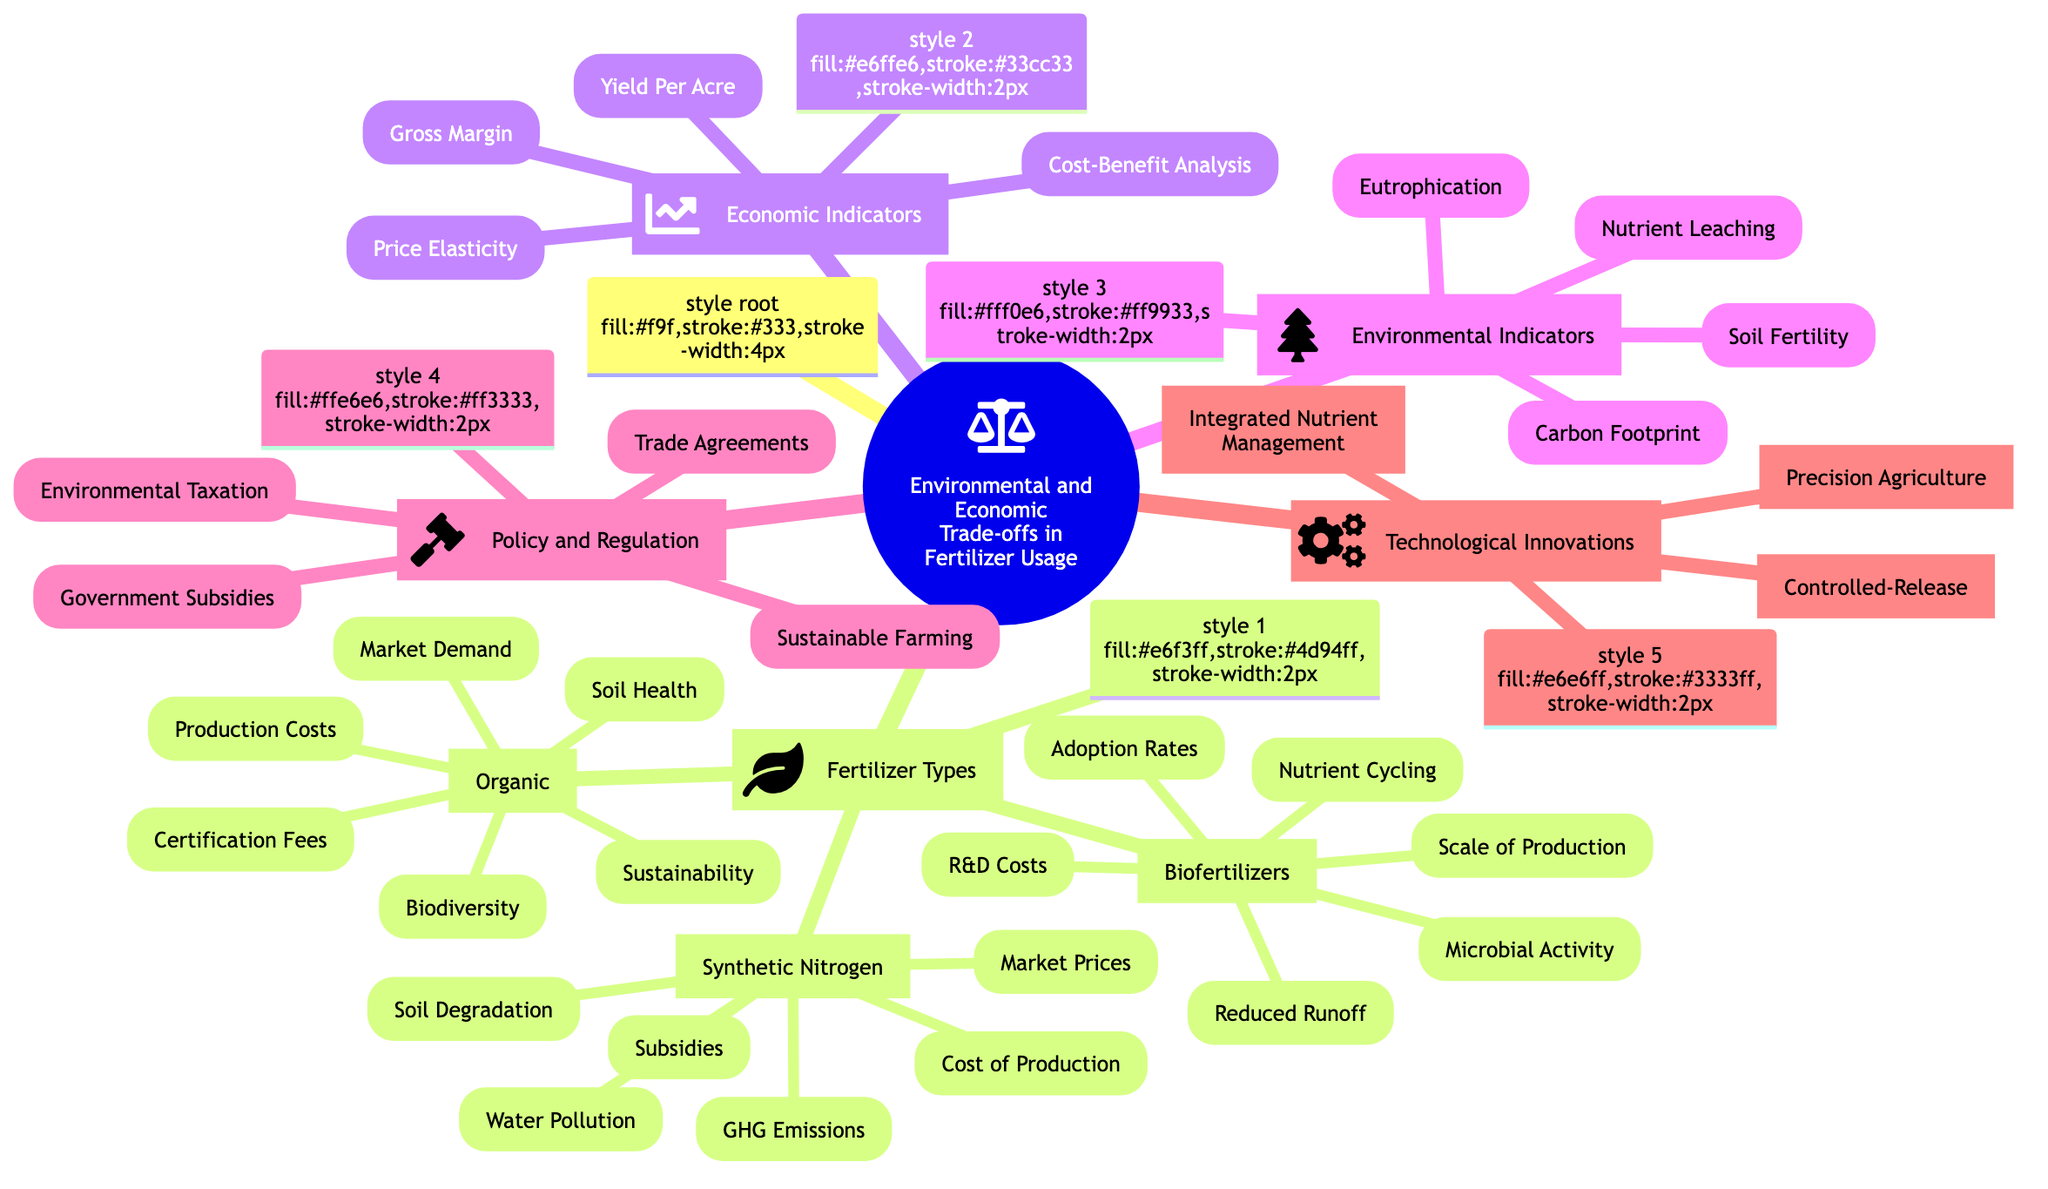What types of fertilizers are included in this diagram? The diagram shows three types of fertilizers: Synthetic Nitrogen, Organic, and Biofertilizers. This information is found directly under "Fertilizer Types."
Answer: Synthetic Nitrogen, Organic, Biofertilizers How many economic implications are listed under Synthetic Nitrogen Fertilizers? Under Synthetic Nitrogen Fertilizers, there are three economic implications listed: Cost of Production, Market Prices, and Subsidies. This count is performed directly on those nodes.
Answer: 3 What environmental implication is associated with Biofertilizers in the diagram? The environmental implications associated with Biofertilizers include Nutrient Cycling, Microbial Activity, and Reduced Chemical Runoff. Any of these can answer the question, as it's looking for just one implication.
Answer: Nutrient Cycling Which type of fertilizer has implications for sustainability? The Organic Fertilizers category explicitly mentions "Sustainability" as one of its environmental implications, deducing it from the respective node's content.
Answer: Organic Fertilizers What is one economic indicator present in the Mind Map? The Economic Indicators section contains elements such as Yield Per Acre, Cost-Benefit Analysis, Gross Margin, and Price Elasticity of Demand, out of which any can be selected. The answer is derived from observing this section's contents.
Answer: Yield Per Acre Which policy is listed under Policy and Regulation? The Policy and Regulation section includes several policies like Government Subsidies, Environmental Taxation, Sustainable Farming Initiatives, and Trade Agreements. Any of these can be an answer as they are all listed under this category.
Answer: Government Subsidies How many environmental implications are listed under Organic Fertilizers? Organic Fertilizers have three environmental implications stated: Sustainability, Soil Health, and Biodiversity. Counting these nodes provides the necessary answer.
Answer: 3 What technology focuses on precise nutrient application? The Technology Innovations section includes an entry for "Precision Agriculture," which directly addresses the concept of precise nutrient application.
Answer: Precision Agriculture What is the relationship between synthetic nitrogen fertilizers and greenhouse gas emissions? Synthetic Nitrogen Fertilizers are associated with greenhouse gas emissions as one of their environmental implications, indicating a direct relationship between them.
Answer: Greenhouse Gas Emissions What is one environmental indicator mentioned in the diagram? The Environmental Indicators section includes elements like Carbon Footprint, Eutrophication Potential, Nutrient Leaching, and Soil Fertility. Any one of these can correctly respond to the inquiry concerning environmental indicators.
Answer: Carbon Footprint 